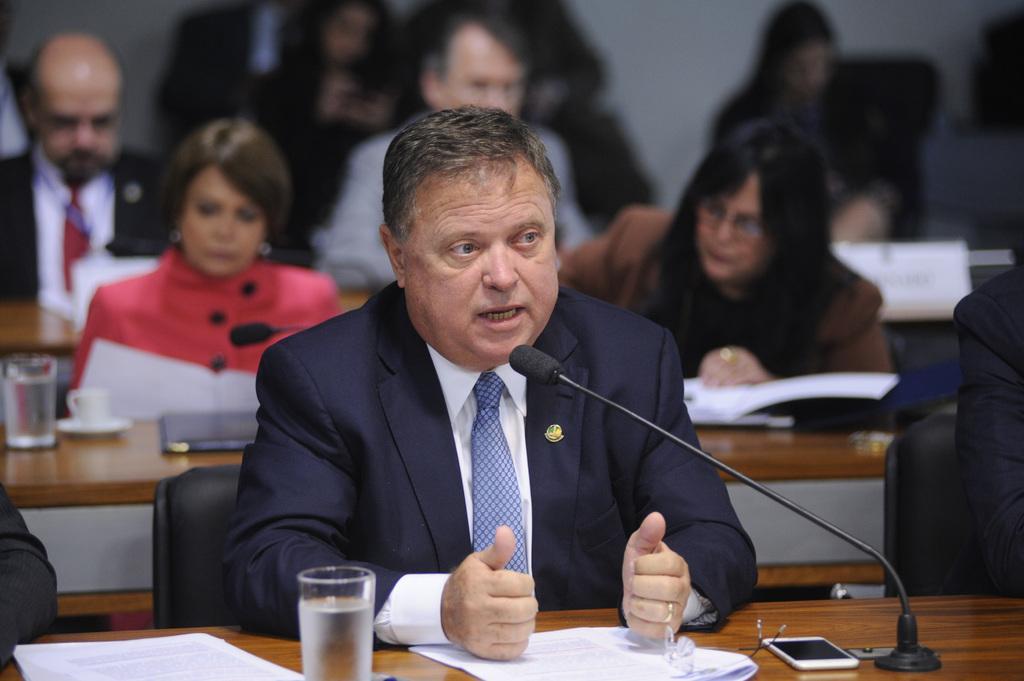How would you summarize this image in a sentence or two? Front this person is sitting on a chair wore a suit and talking in-front of this mic. On this table there are papers, spectacles, mobile, mice and a glass of water. Background it is blur. We can see people and tables. 